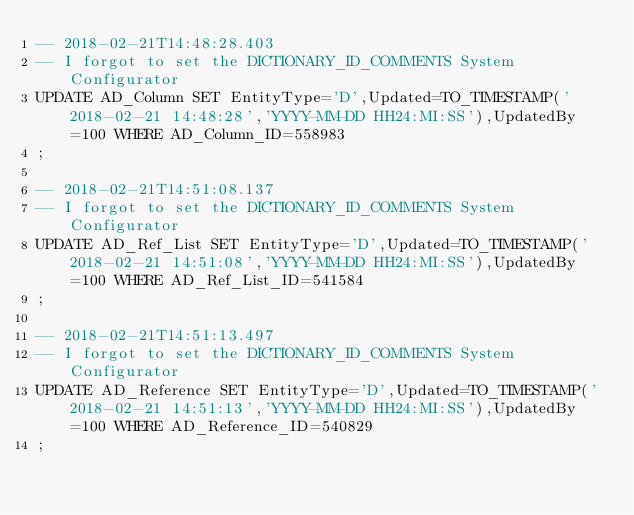<code> <loc_0><loc_0><loc_500><loc_500><_SQL_>-- 2018-02-21T14:48:28.403
-- I forgot to set the DICTIONARY_ID_COMMENTS System Configurator
UPDATE AD_Column SET EntityType='D',Updated=TO_TIMESTAMP('2018-02-21 14:48:28','YYYY-MM-DD HH24:MI:SS'),UpdatedBy=100 WHERE AD_Column_ID=558983
;

-- 2018-02-21T14:51:08.137
-- I forgot to set the DICTIONARY_ID_COMMENTS System Configurator
UPDATE AD_Ref_List SET EntityType='D',Updated=TO_TIMESTAMP('2018-02-21 14:51:08','YYYY-MM-DD HH24:MI:SS'),UpdatedBy=100 WHERE AD_Ref_List_ID=541584
;

-- 2018-02-21T14:51:13.497
-- I forgot to set the DICTIONARY_ID_COMMENTS System Configurator
UPDATE AD_Reference SET EntityType='D',Updated=TO_TIMESTAMP('2018-02-21 14:51:13','YYYY-MM-DD HH24:MI:SS'),UpdatedBy=100 WHERE AD_Reference_ID=540829
;

</code> 